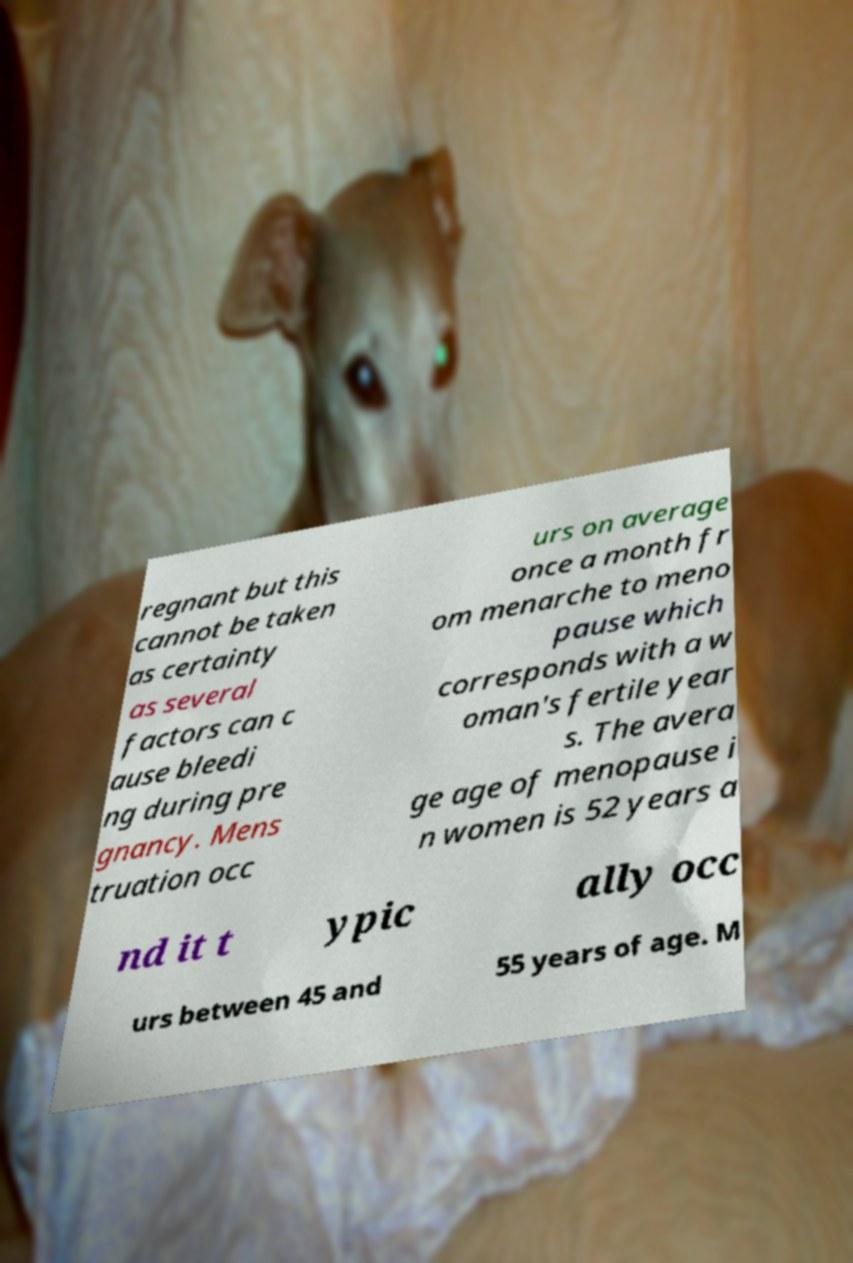Can you read and provide the text displayed in the image?This photo seems to have some interesting text. Can you extract and type it out for me? regnant but this cannot be taken as certainty as several factors can c ause bleedi ng during pre gnancy. Mens truation occ urs on average once a month fr om menarche to meno pause which corresponds with a w oman's fertile year s. The avera ge age of menopause i n women is 52 years a nd it t ypic ally occ urs between 45 and 55 years of age. M 